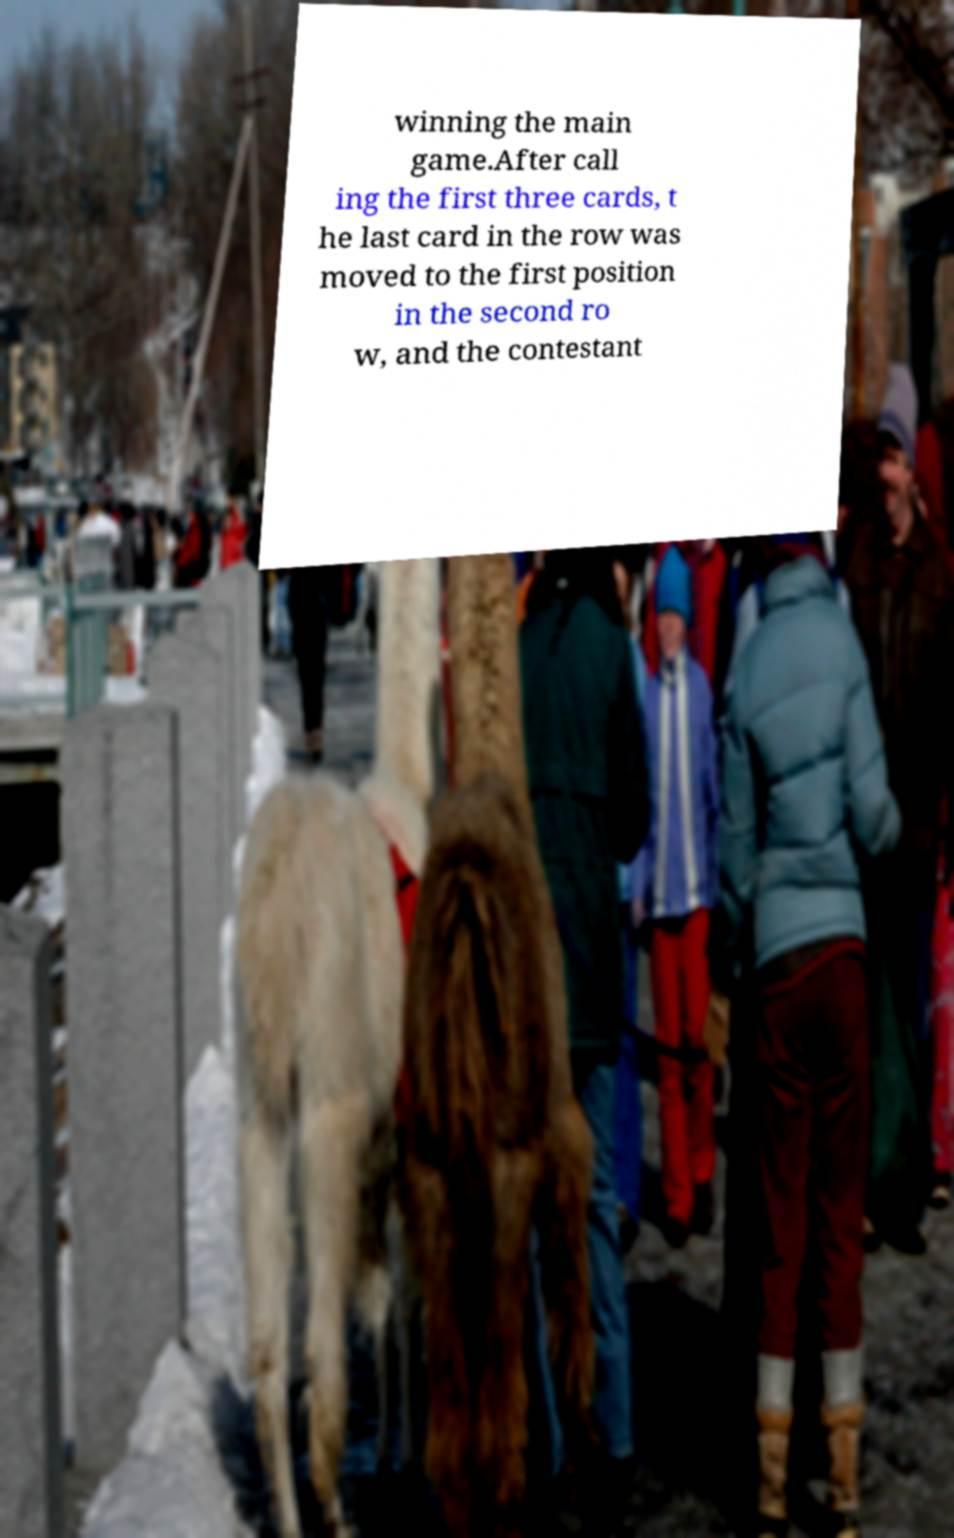For documentation purposes, I need the text within this image transcribed. Could you provide that? winning the main game.After call ing the first three cards, t he last card in the row was moved to the first position in the second ro w, and the contestant 